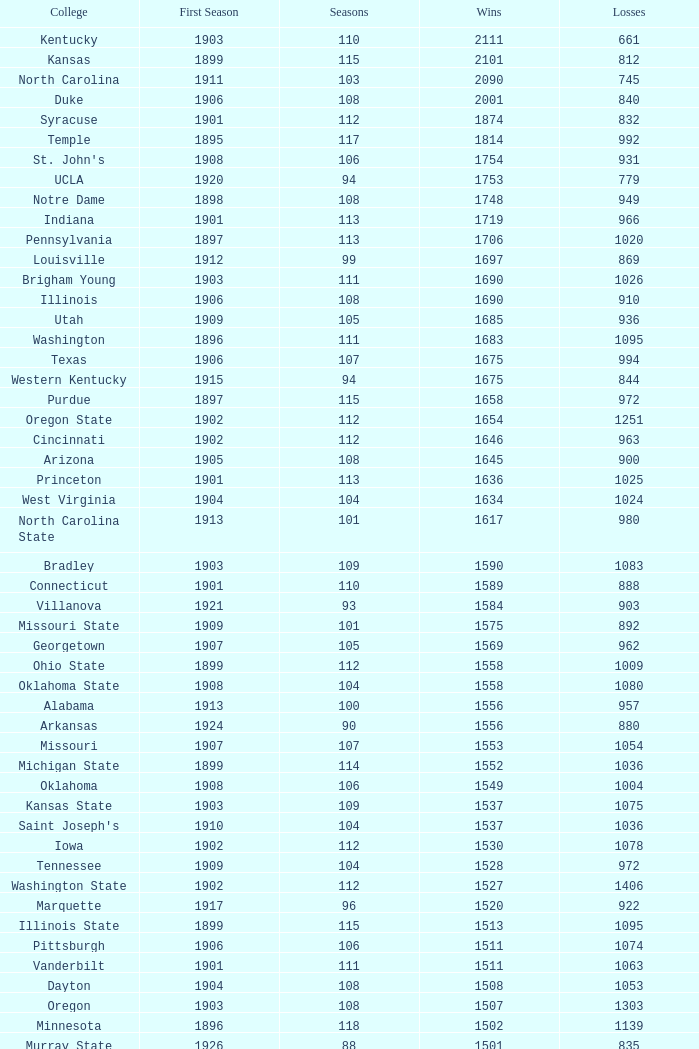What is the total of First Season games with 1537 Wins and a Season greater than 109? None. Could you parse the entire table? {'header': ['College', 'First Season', 'Seasons', 'Wins', 'Losses'], 'rows': [['Kentucky', '1903', '110', '2111', '661'], ['Kansas', '1899', '115', '2101', '812'], ['North Carolina', '1911', '103', '2090', '745'], ['Duke', '1906', '108', '2001', '840'], ['Syracuse', '1901', '112', '1874', '832'], ['Temple', '1895', '117', '1814', '992'], ["St. John's", '1908', '106', '1754', '931'], ['UCLA', '1920', '94', '1753', '779'], ['Notre Dame', '1898', '108', '1748', '949'], ['Indiana', '1901', '113', '1719', '966'], ['Pennsylvania', '1897', '113', '1706', '1020'], ['Louisville', '1912', '99', '1697', '869'], ['Brigham Young', '1903', '111', '1690', '1026'], ['Illinois', '1906', '108', '1690', '910'], ['Utah', '1909', '105', '1685', '936'], ['Washington', '1896', '111', '1683', '1095'], ['Texas', '1906', '107', '1675', '994'], ['Western Kentucky', '1915', '94', '1675', '844'], ['Purdue', '1897', '115', '1658', '972'], ['Oregon State', '1902', '112', '1654', '1251'], ['Cincinnati', '1902', '112', '1646', '963'], ['Arizona', '1905', '108', '1645', '900'], ['Princeton', '1901', '113', '1636', '1025'], ['West Virginia', '1904', '104', '1634', '1024'], ['North Carolina State', '1913', '101', '1617', '980'], ['Bradley', '1903', '109', '1590', '1083'], ['Connecticut', '1901', '110', '1589', '888'], ['Villanova', '1921', '93', '1584', '903'], ['Missouri State', '1909', '101', '1575', '892'], ['Georgetown', '1907', '105', '1569', '962'], ['Ohio State', '1899', '112', '1558', '1009'], ['Oklahoma State', '1908', '104', '1558', '1080'], ['Alabama', '1913', '100', '1556', '957'], ['Arkansas', '1924', '90', '1556', '880'], ['Missouri', '1907', '107', '1553', '1054'], ['Michigan State', '1899', '114', '1552', '1036'], ['Oklahoma', '1908', '106', '1549', '1004'], ['Kansas State', '1903', '109', '1537', '1075'], ["Saint Joseph's", '1910', '104', '1537', '1036'], ['Iowa', '1902', '112', '1530', '1078'], ['Tennessee', '1909', '104', '1528', '972'], ['Washington State', '1902', '112', '1527', '1406'], ['Marquette', '1917', '96', '1520', '922'], ['Illinois State', '1899', '115', '1513', '1095'], ['Pittsburgh', '1906', '106', '1511', '1074'], ['Vanderbilt', '1901', '111', '1511', '1063'], ['Dayton', '1904', '108', '1508', '1053'], ['Oregon', '1903', '108', '1507', '1303'], ['Minnesota', '1896', '118', '1502', '1139'], ['Murray State', '1926', '88', '1501', '835']]} 